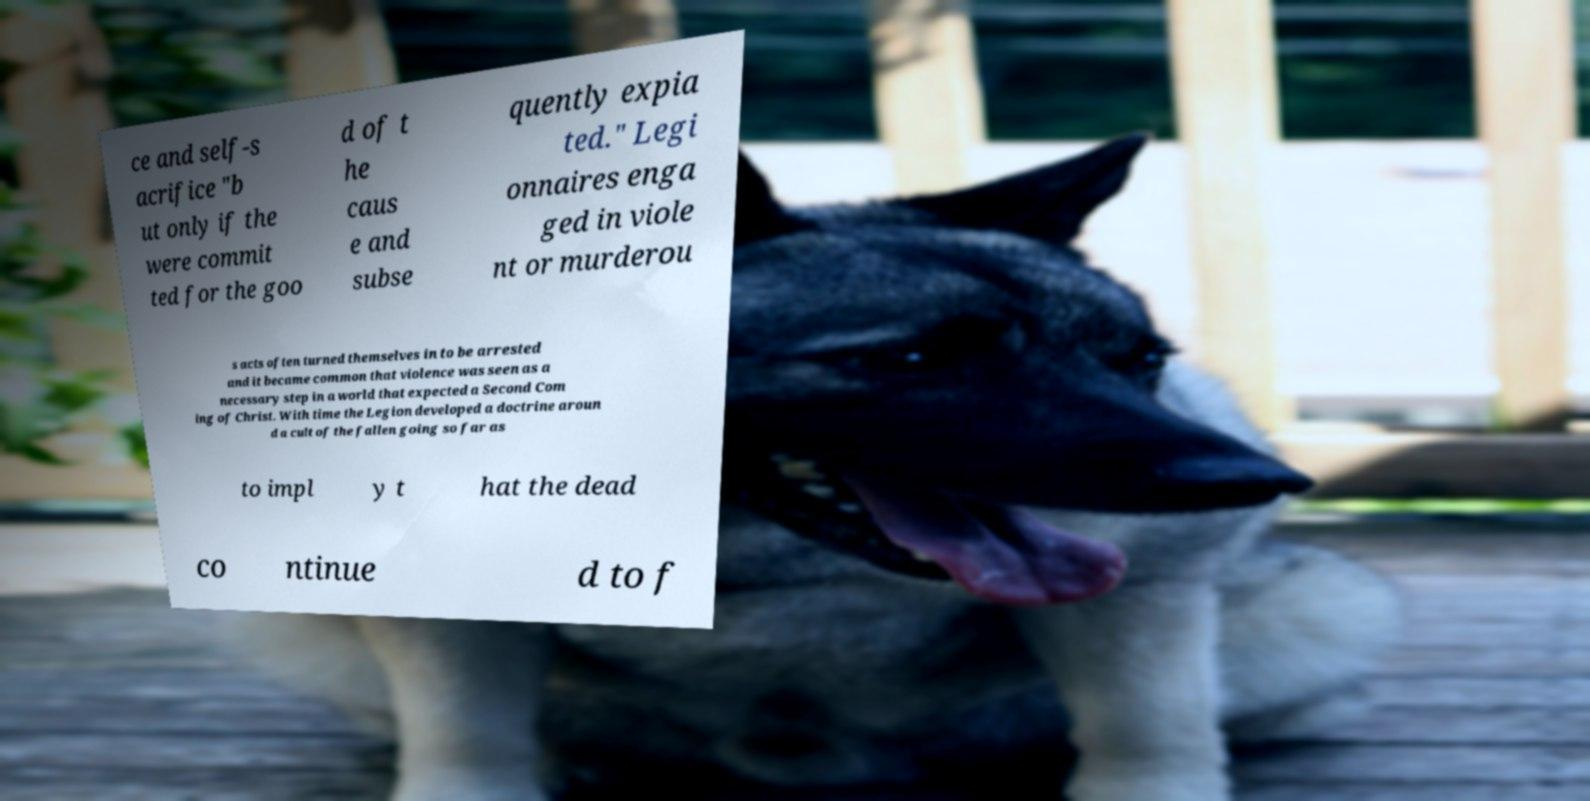I need the written content from this picture converted into text. Can you do that? ce and self-s acrifice "b ut only if the were commit ted for the goo d of t he caus e and subse quently expia ted." Legi onnaires enga ged in viole nt or murderou s acts often turned themselves in to be arrested and it became common that violence was seen as a necessary step in a world that expected a Second Com ing of Christ. With time the Legion developed a doctrine aroun d a cult of the fallen going so far as to impl y t hat the dead co ntinue d to f 